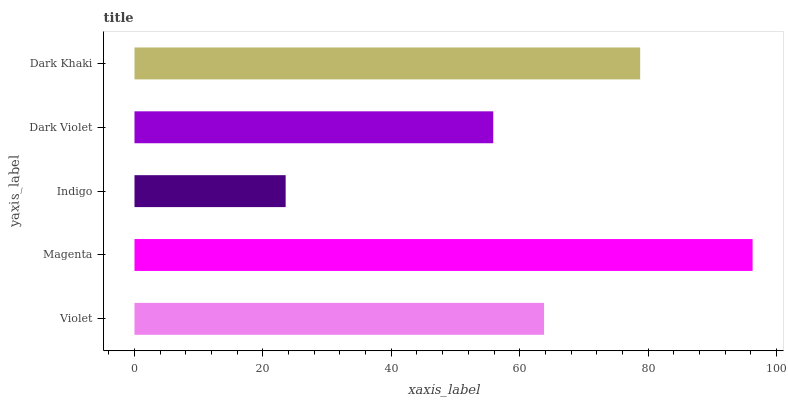Is Indigo the minimum?
Answer yes or no. Yes. Is Magenta the maximum?
Answer yes or no. Yes. Is Magenta the minimum?
Answer yes or no. No. Is Indigo the maximum?
Answer yes or no. No. Is Magenta greater than Indigo?
Answer yes or no. Yes. Is Indigo less than Magenta?
Answer yes or no. Yes. Is Indigo greater than Magenta?
Answer yes or no. No. Is Magenta less than Indigo?
Answer yes or no. No. Is Violet the high median?
Answer yes or no. Yes. Is Violet the low median?
Answer yes or no. Yes. Is Indigo the high median?
Answer yes or no. No. Is Dark Khaki the low median?
Answer yes or no. No. 